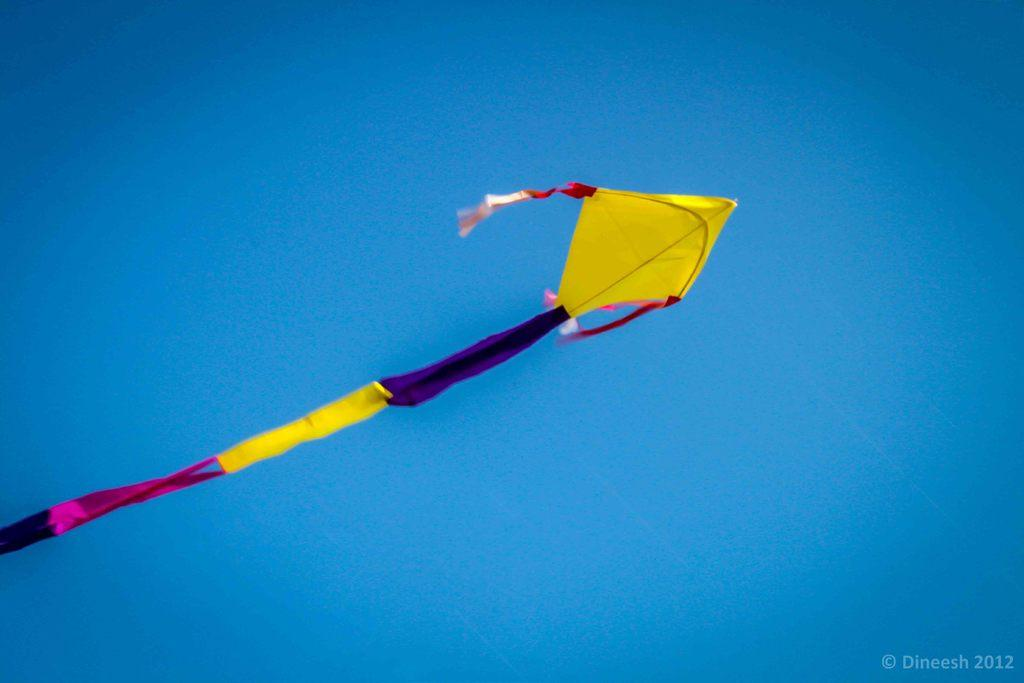What is the main object in the image? There is a colorful kite in the image. Where is the kite located? The kite is in the blue sky. Is there any text present in the image? Yes, there is some text on the right side of the image. What type of note is being played by the kite in the image? There is no note being played by the kite in the image, as kites are not musical instruments. 